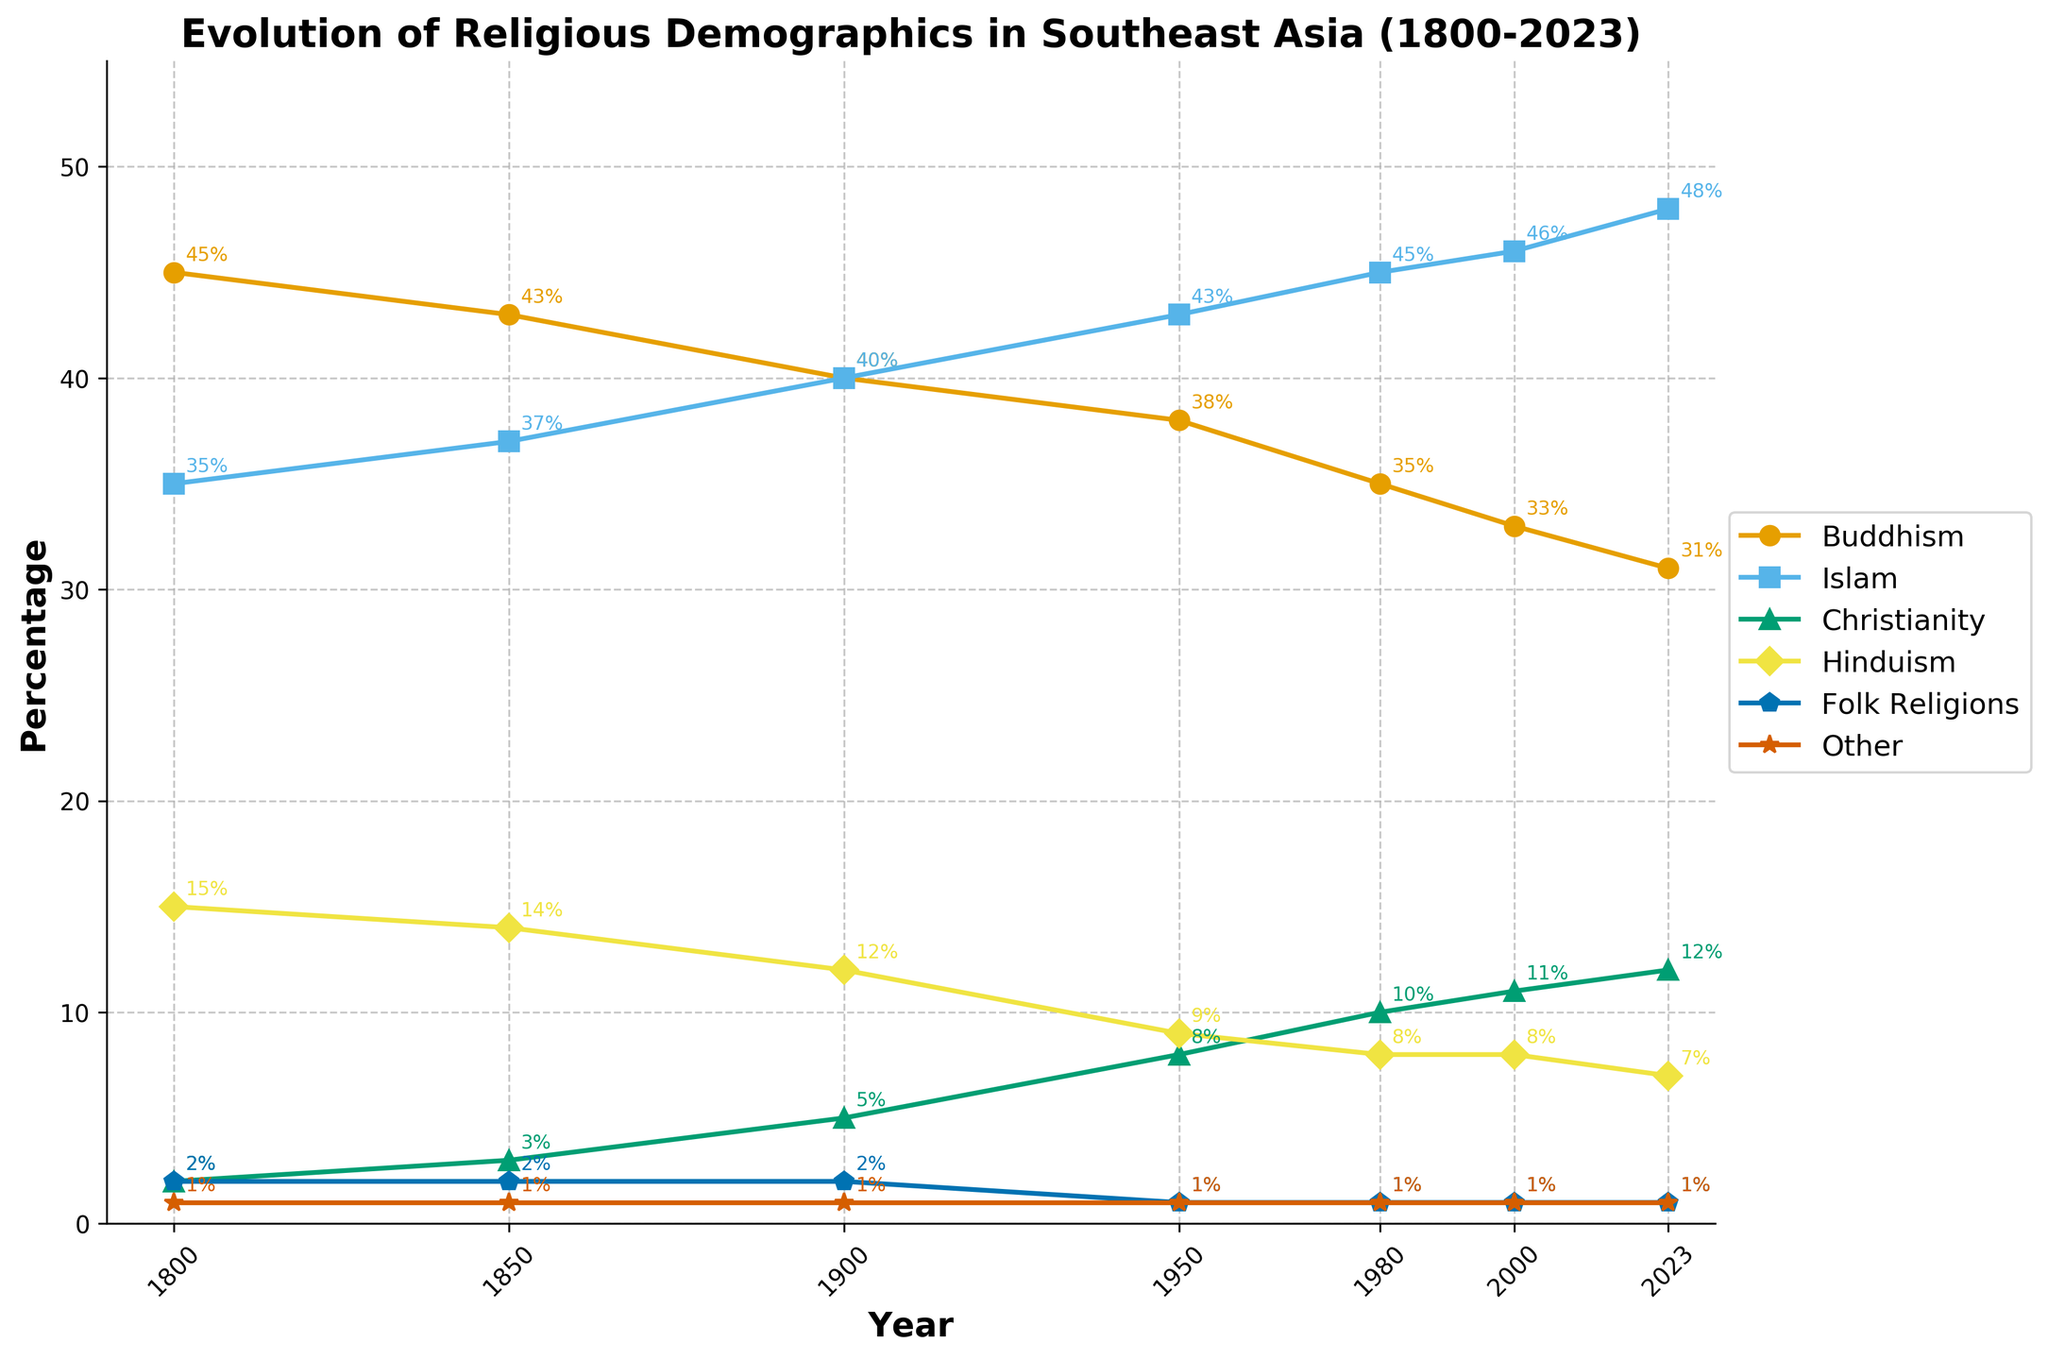What was the percentage of Christianity in 1900 compared to 2000? From the plot, we see that the percentage of Christianity in 1900 was 5%, and in 2000 it increased to 11%. We compare these values directly.
Answer: 5% in 1900, 11% in 2000 Which religion has shown the most consistent increase from 1800 to 2023? Observing the plot, Islam has shown a consistently increasing trend from 35% in 1800 to 48% in 2023.
Answer: Islam How much has the percentage of Buddhism declined from 1800 to 2023? Buddhism started at 45% in 1800 and declined to 31% in 2023. The difference is calculated as 45 - 31.
Answer: 14% In what year did Christianity surpass 10%? By examining the trend line for Christianity, we see that it surpassed 10% between 1950 and 1980, and reached 11% in 2000.
Answer: 2000 What visual pattern indicates the impact of colonial missionary activities on Christianity? The sharp increase in the line representing Christianity starting around the 19th and 20th centuries (from 2% in 1800 to 12% in 2023) suggests increased missionary activities during colonial periods.
Answer: Sharp increase in Christianity percentages Which two religions have shown a significant decrease in percentage over the period from 1800 to 2023? Looking at the plot, both Buddhism (from 45% to 31%) and Hinduism (from 15% to 7%) have shown significant decreases.
Answer: Buddhism and Hinduism What is the combined percentage of all religions except Islam in 2023, and how does it compare to 1800? In 2023, the combined percentage of all religions except Islam is 31 (Buddhism) + 12 (Christianity) + 7 (Hinduism) + 1 (Folk Religions) + 1 (Other) = 52%. In 1800, it was 45 + 2 + 15 + 2 + 1 = 65%. The comparison shows a decrease in the combined percentage from 65% to 52%.
Answer: 52% in 2023, 65% in 1800, decrease Has any religion remained relatively unchanged over the years? The percentage of "Other" religions has stayed constant at 1% from 1800 to 2023, indicating minimal changes.
Answer: Other 